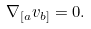Convert formula to latex. <formula><loc_0><loc_0><loc_500><loc_500>\nabla _ { [ a } v _ { b ] } = 0 .</formula> 